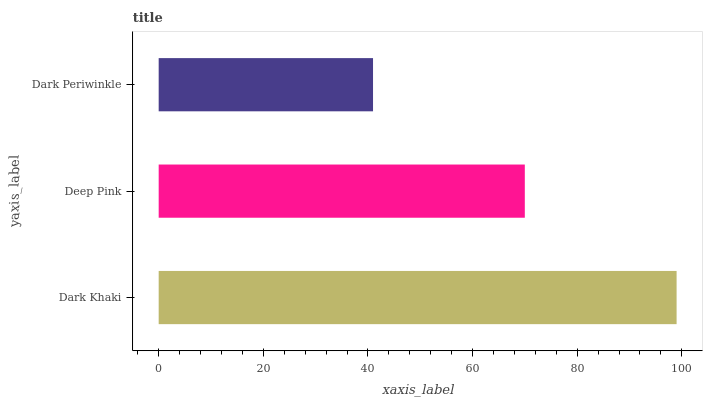Is Dark Periwinkle the minimum?
Answer yes or no. Yes. Is Dark Khaki the maximum?
Answer yes or no. Yes. Is Deep Pink the minimum?
Answer yes or no. No. Is Deep Pink the maximum?
Answer yes or no. No. Is Dark Khaki greater than Deep Pink?
Answer yes or no. Yes. Is Deep Pink less than Dark Khaki?
Answer yes or no. Yes. Is Deep Pink greater than Dark Khaki?
Answer yes or no. No. Is Dark Khaki less than Deep Pink?
Answer yes or no. No. Is Deep Pink the high median?
Answer yes or no. Yes. Is Deep Pink the low median?
Answer yes or no. Yes. Is Dark Periwinkle the high median?
Answer yes or no. No. Is Dark Periwinkle the low median?
Answer yes or no. No. 